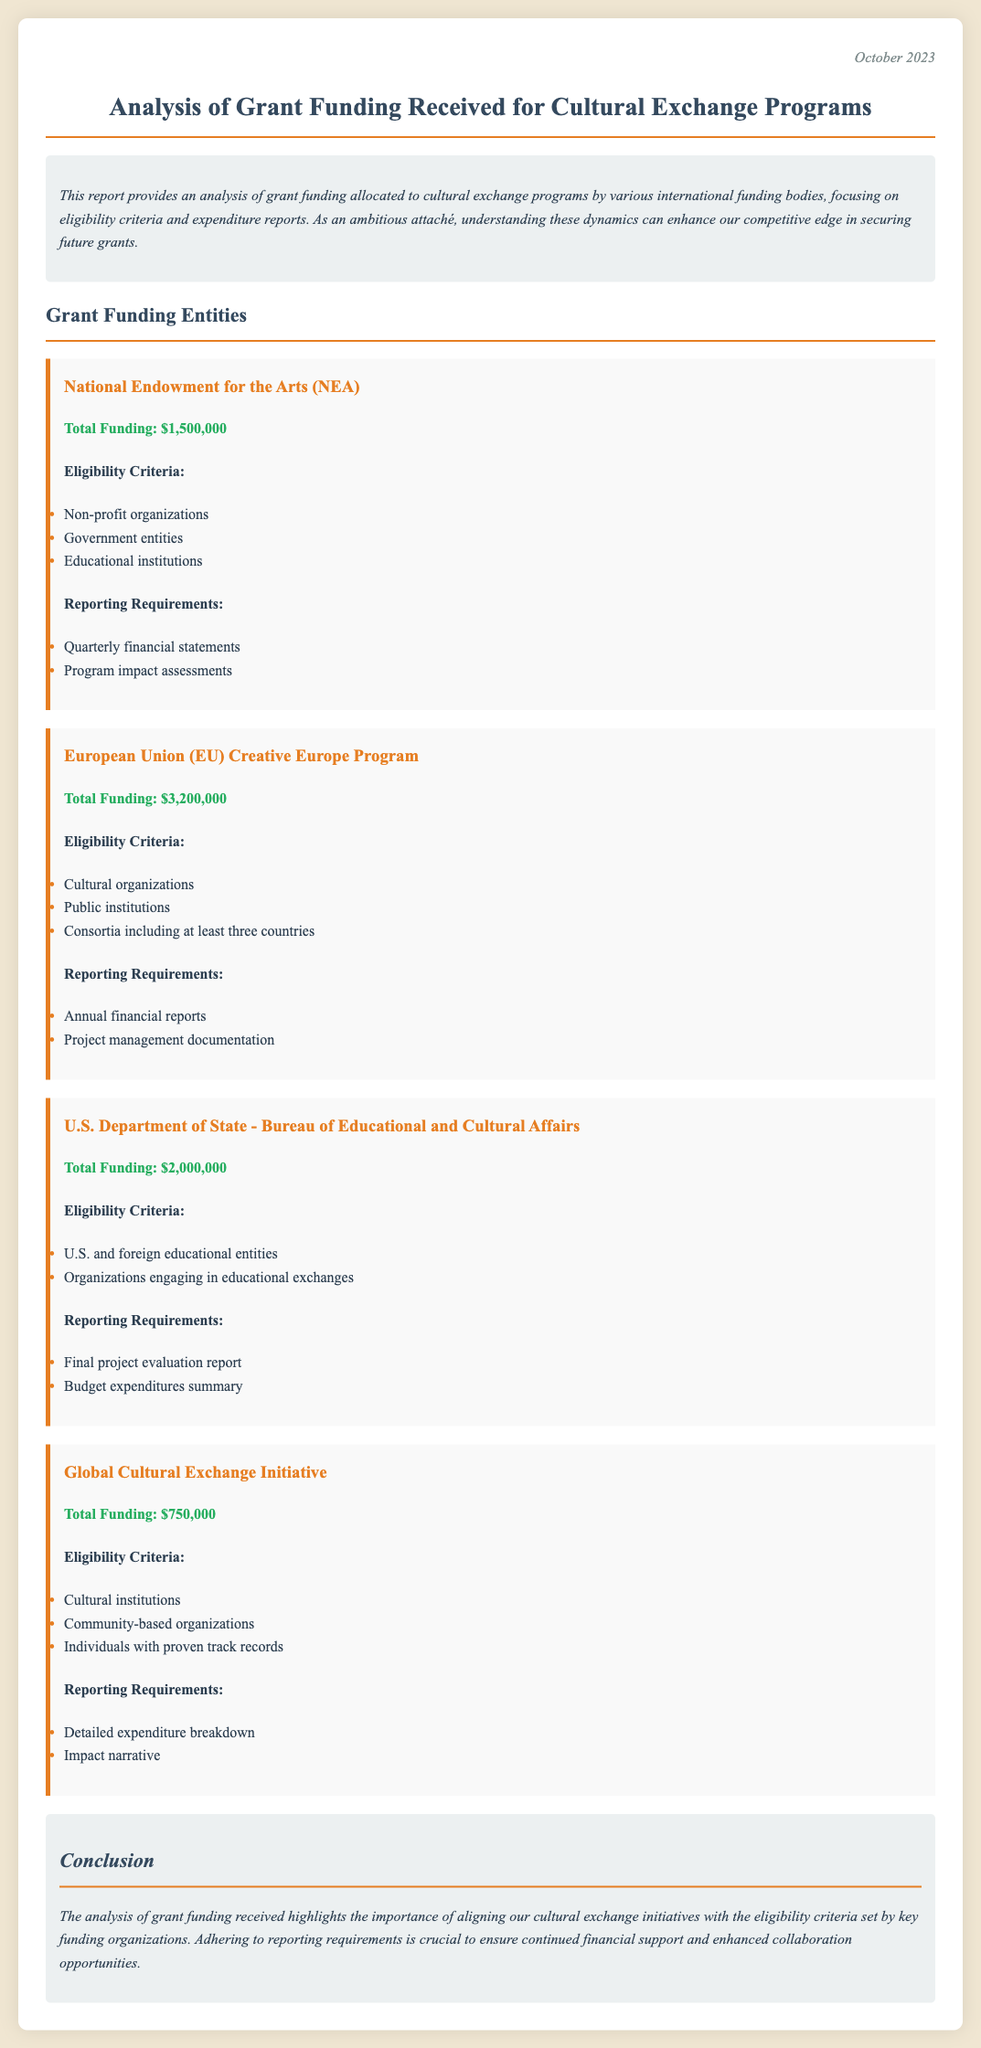What is the total funding from the National Endowment for the Arts? The total funding from the National Endowment for the Arts is specified in the document as $1,500,000.
Answer: $1,500,000 What are the eligibility criteria for the European Union Creative Europe Program? The eligibility criteria are listed in a bullet point format, including cultural organizations, public institutions, and consortia including at least three countries.
Answer: Cultural organizations, public institutions, consortia including at least three countries How much total funding is allocated to the Global Cultural Exchange Initiative? The total funding allocated to the Global Cultural Exchange Initiative is mentioned as $750,000.
Answer: $750,000 What is one of the reporting requirements for the U.S. Department of State? The reporting requirements include a final project evaluation report and a budget expenditures summary. One of them is the final project evaluation report.
Answer: Final project evaluation report Which funding entity provides the highest total funding? A comparison of the total funding amounts shows that the European Union Creative Europe Program provides the highest total funding at $3,200,000.
Answer: European Union Creative Europe Program What is the date of the report? The date of the report is located at the top right, indicating it was published in October 2023.
Answer: October 2023 What type of organizations are eligible for funding from the National Endowment for the Arts? The eligible organizations include non-profit organizations, government entities, and educational institutions, as listed in the criteria.
Answer: Non-profit organizations, government entities, educational institutions What type of breakdown is required in the reporting for the Global Cultural Exchange Initiative? The reporting requirements specify a detailed expenditure breakdown.
Answer: Detailed expenditure breakdown What other key requirement is necessary to secure future grants according to the conclusion? The conclusion emphasizes the importance of adhering to reporting requirements to ensure continued financial support and collaboration opportunities.
Answer: Adhering to reporting requirements 